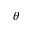Convert formula to latex. <formula><loc_0><loc_0><loc_500><loc_500>\theta</formula> 